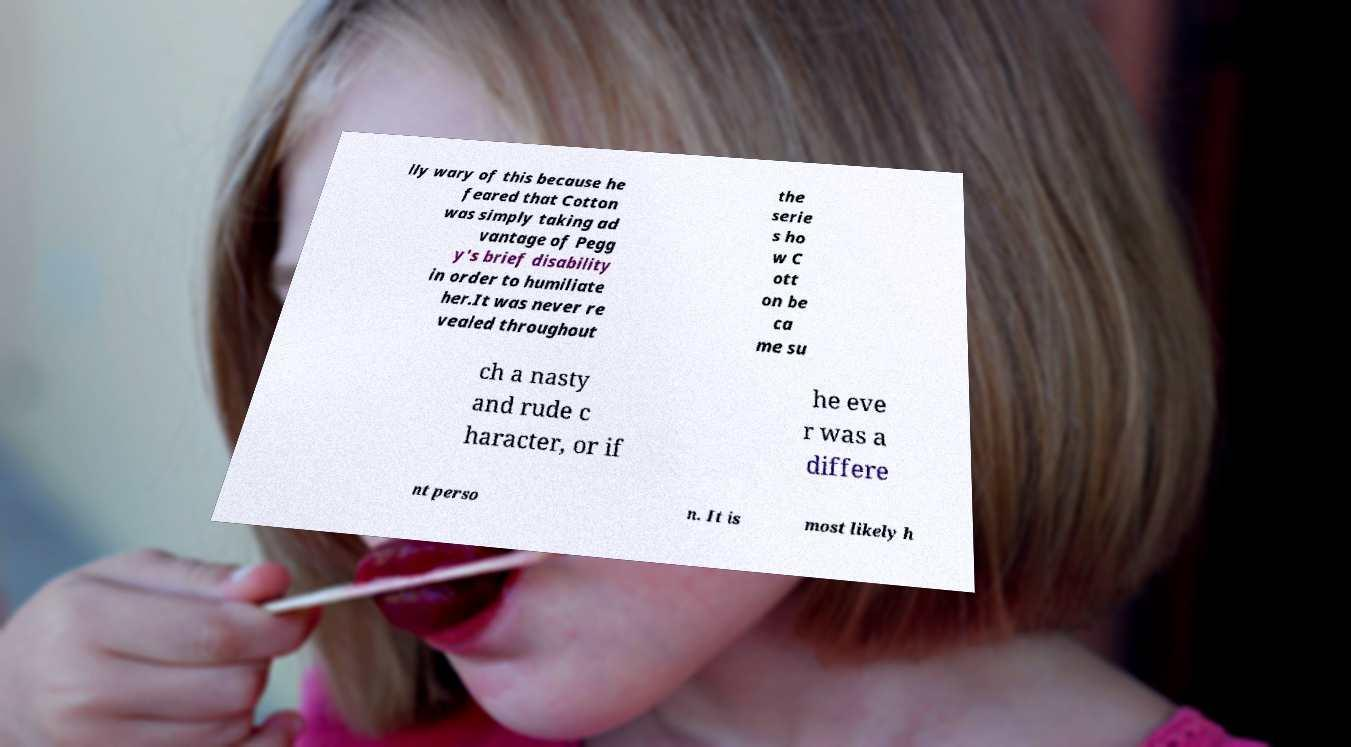Please read and relay the text visible in this image. What does it say? lly wary of this because he feared that Cotton was simply taking ad vantage of Pegg y's brief disability in order to humiliate her.It was never re vealed throughout the serie s ho w C ott on be ca me su ch a nasty and rude c haracter, or if he eve r was a differe nt perso n. It is most likely h 